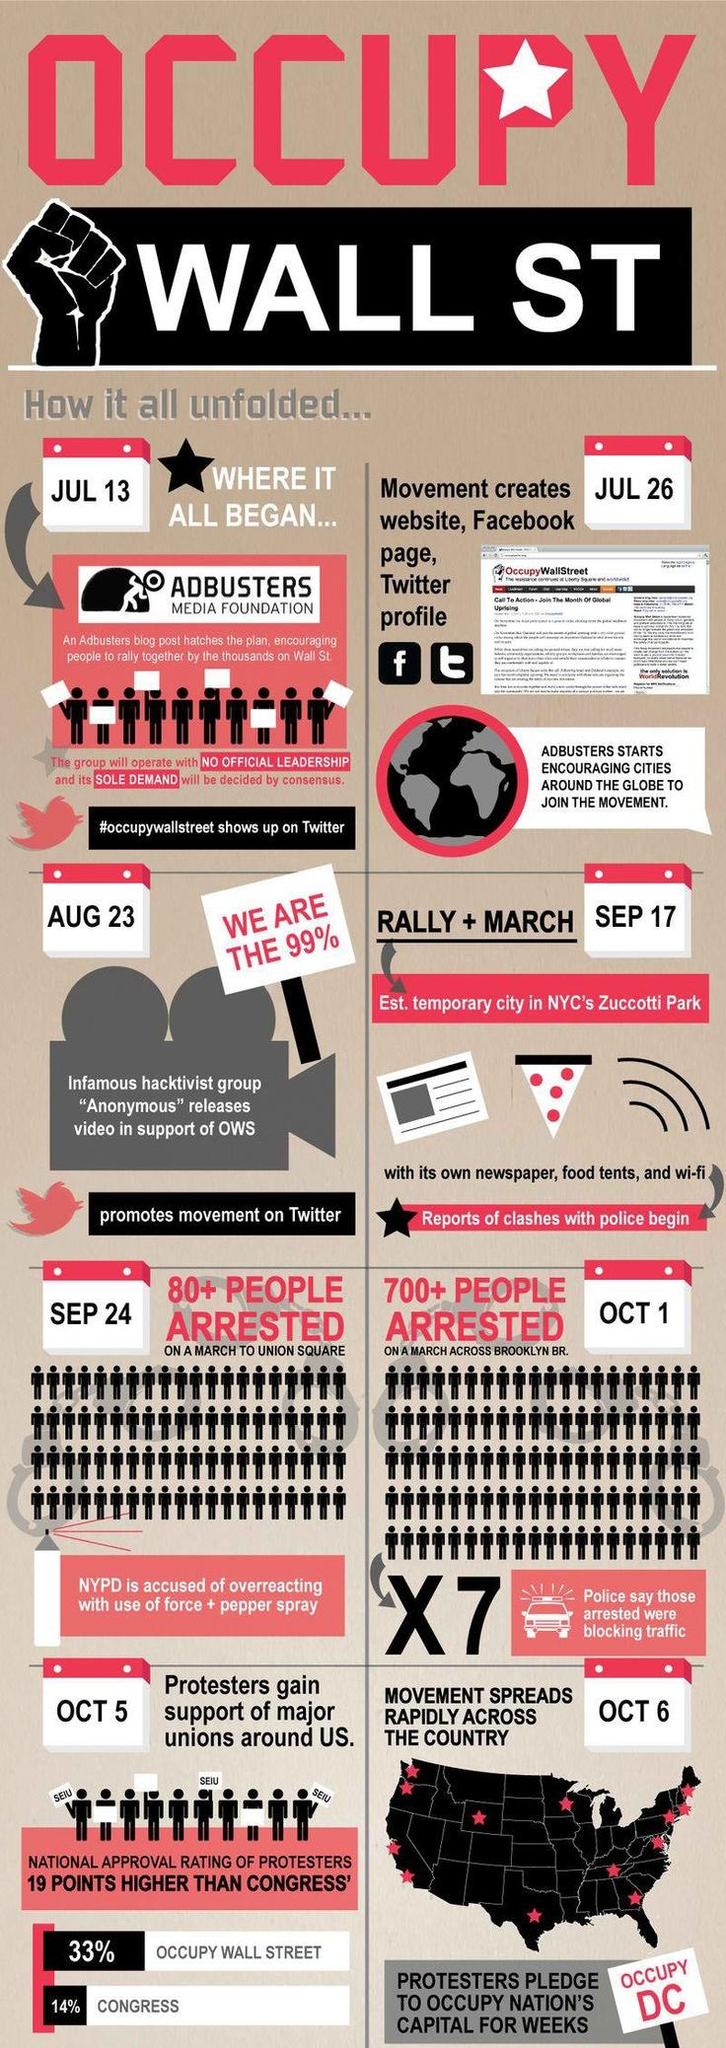Highlight a few significant elements in this photo. On the march to the Brooklyn branch, a large number of people were arrested, estimated to be over 700 people. The Adbusters Media Foundation is unique in that it has no official leadership and relies solely on public demand. On October 1st, the march to the Brooklyn branch took place. According to a recent survey, 67% of people surveyed support Wall Street. 